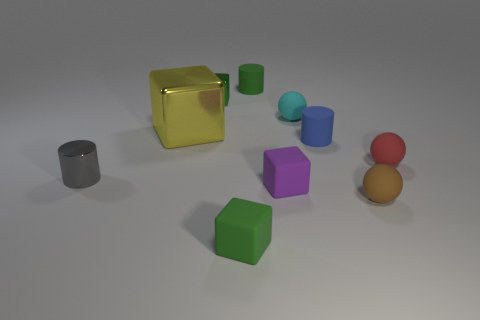Is the number of tiny balls that are behind the tiny brown rubber thing less than the number of metal cylinders?
Ensure brevity in your answer.  No. Is the gray cylinder made of the same material as the large thing?
Give a very brief answer. Yes. What number of objects are either tiny red rubber spheres or big red rubber things?
Provide a short and direct response. 1. What number of small cyan things are made of the same material as the red thing?
Ensure brevity in your answer.  1. What is the size of the gray thing that is the same shape as the small blue object?
Offer a terse response. Small. Are there any large metal cubes right of the red rubber sphere?
Offer a very short reply. No. What is the material of the blue object?
Offer a very short reply. Rubber. There is a cylinder that is to the left of the green matte cylinder; is it the same color as the big shiny block?
Give a very brief answer. No. Is there anything else that is the same shape as the small green metal object?
Ensure brevity in your answer.  Yes. What is the color of the other large metallic object that is the same shape as the green metallic thing?
Make the answer very short. Yellow. 